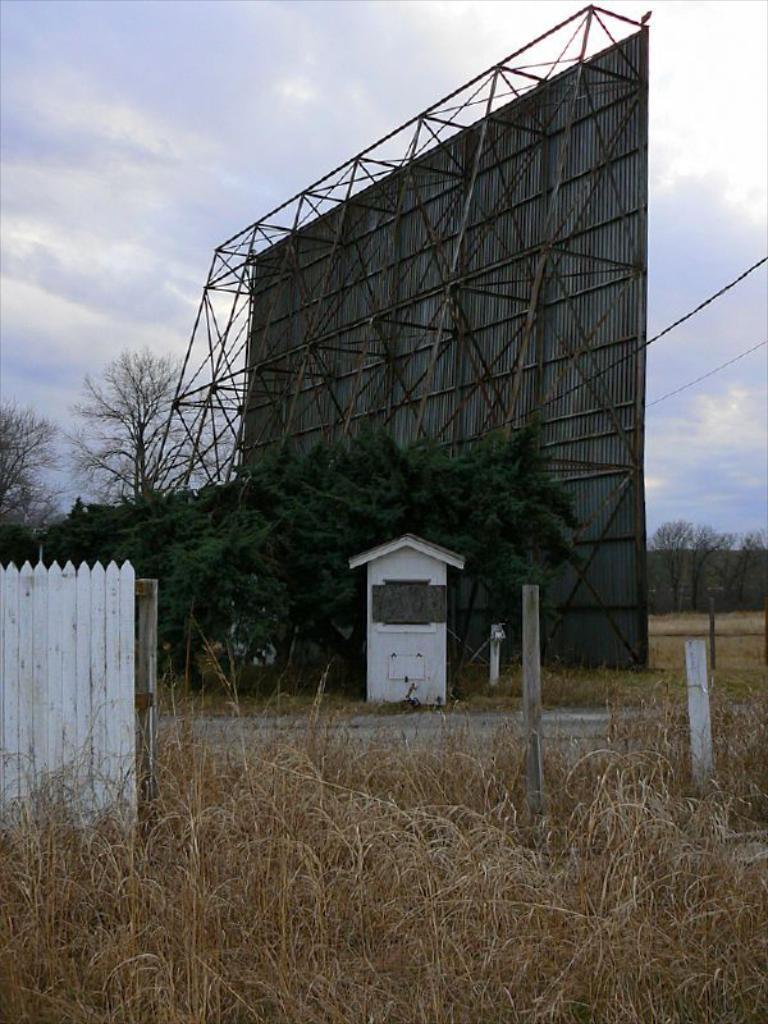Describe this image in one or two sentences. In this image we can see a metal frame with a banner and a house with a roof. We can also see some poles, plants, a fence, a group of trees, a wire and the sky which looks cloudy. 